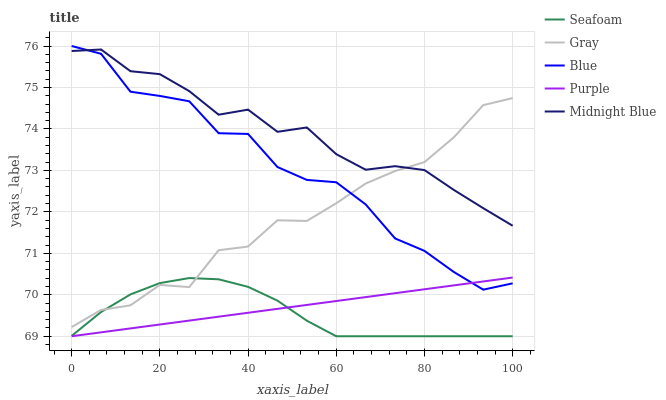Does Seafoam have the minimum area under the curve?
Answer yes or no. Yes. Does Midnight Blue have the maximum area under the curve?
Answer yes or no. Yes. Does Gray have the minimum area under the curve?
Answer yes or no. No. Does Gray have the maximum area under the curve?
Answer yes or no. No. Is Purple the smoothest?
Answer yes or no. Yes. Is Blue the roughest?
Answer yes or no. Yes. Is Gray the smoothest?
Answer yes or no. No. Is Gray the roughest?
Answer yes or no. No. Does Seafoam have the lowest value?
Answer yes or no. Yes. Does Gray have the lowest value?
Answer yes or no. No. Does Blue have the highest value?
Answer yes or no. Yes. Does Gray have the highest value?
Answer yes or no. No. Is Seafoam less than Midnight Blue?
Answer yes or no. Yes. Is Gray greater than Purple?
Answer yes or no. Yes. Does Purple intersect Blue?
Answer yes or no. Yes. Is Purple less than Blue?
Answer yes or no. No. Is Purple greater than Blue?
Answer yes or no. No. Does Seafoam intersect Midnight Blue?
Answer yes or no. No. 